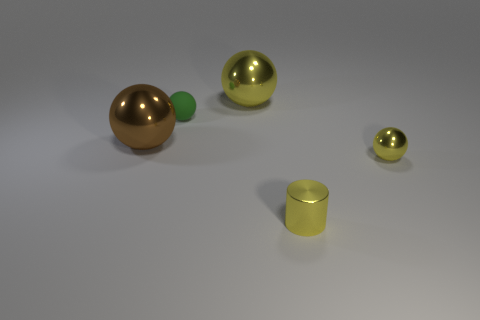How many things are shiny balls in front of the big brown metallic ball or yellow shiny spheres to the right of the brown metallic ball?
Your answer should be very brief. 2. The rubber thing is what color?
Ensure brevity in your answer.  Green. Is the number of cylinders that are behind the cylinder less than the number of objects?
Provide a succinct answer. Yes. Are there any other things that have the same shape as the brown thing?
Your answer should be compact. Yes. Are there any tiny yellow cylinders?
Offer a very short reply. Yes. Are there fewer gray cylinders than brown things?
Give a very brief answer. Yes. How many yellow things have the same material as the brown sphere?
Your response must be concise. 3. There is a tiny cylinder that is the same material as the tiny yellow sphere; what color is it?
Your answer should be compact. Yellow. There is a tiny matte thing; what shape is it?
Your answer should be compact. Sphere. What number of other metallic cylinders are the same color as the cylinder?
Offer a terse response. 0. 